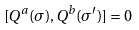<formula> <loc_0><loc_0><loc_500><loc_500>[ Q ^ { a } ( \sigma ) , Q ^ { b } ( \sigma ^ { \prime } ) ] = 0</formula> 